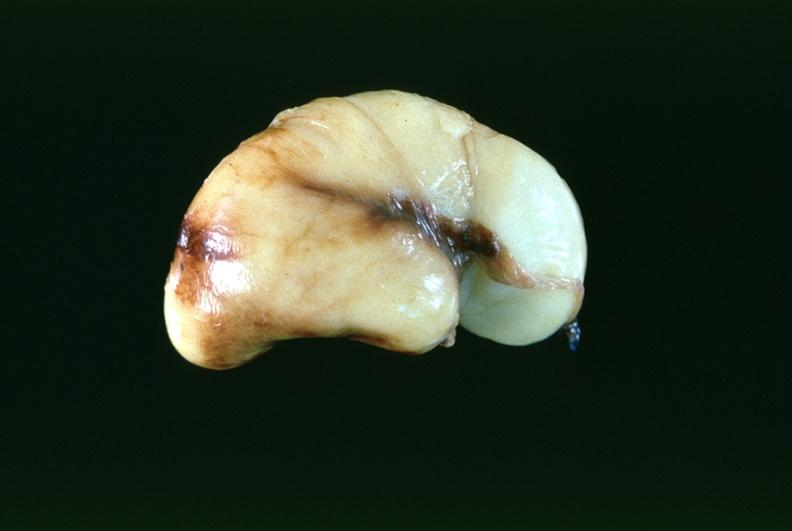s nervous present?
Answer the question using a single word or phrase. Yes 